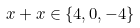<formula> <loc_0><loc_0><loc_500><loc_500>x + x \in \{ 4 , 0 , - 4 \}</formula> 